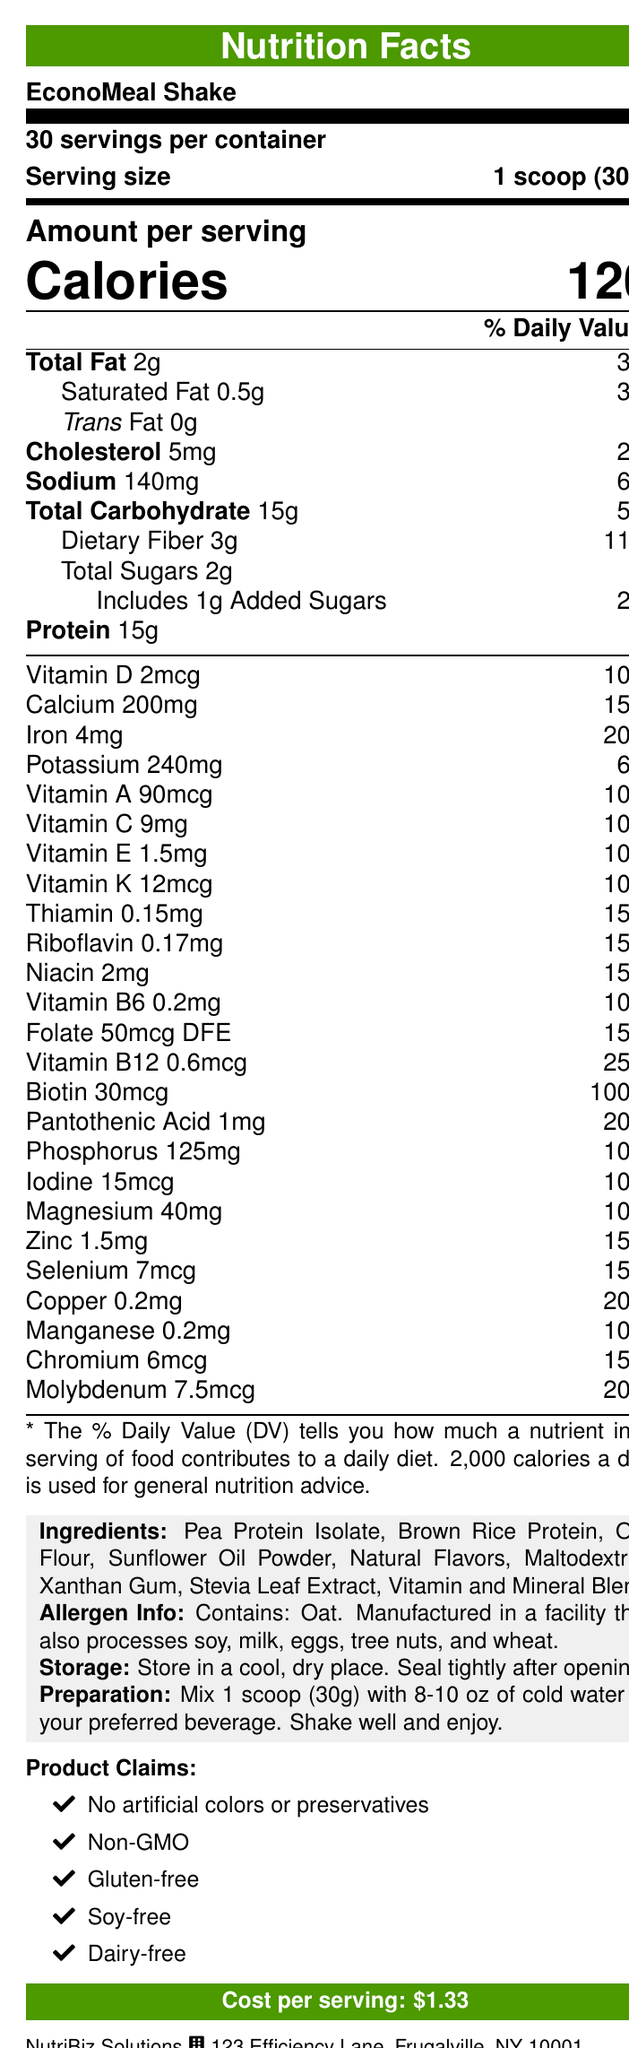what is the product name? The product name is clearly mentioned at the beginning of the document.
Answer: EconoMeal Shake how many servings does the EconoMeal Shake container provide? The document states "30 servings per container."
Answer: 30 servings how many calories are in one serving? The document shows "Calories 120" under the "Amount per serving" section.
Answer: 120 calories what is the serving size? The serving size is listed as "1 scoop (30g)".
Answer: 1 scoop (30g) what is the cost per serving? The cost per serving is highlighted near the bottom of the document.
Answer: $1.33 which nutrient has the highest daily value percentage? A. Iron B. Biotin C. Protein D. Calcium Biotin has the highest daily value percentage at 100%.
Answer: B how much sodium is in one serving? A. 140mg B. 150mg C. 130mg The document states that there are 140mg of sodium per serving.
Answer: A does the product contain any trans fat? According to the document, trans fat is listed as "0g".
Answer: No is the EconoMeal Shake gluten-free? "Gluten-free" is one of the product claims listed in the document.
Answer: Yes is EconoMeal Shake suitable for people with oat allergies? The document mentions that the product contains oat.
Answer: No summarize the main nutritional features of EconoMeal Shake. The summary highlights the main nutritional features, claims, and cost of the EconoMeal Shake based on the information provided in the document.
Answer: The EconoMeal Shake is a budget-friendly meal replacement with 120 calories per serving, providing a balanced mix of macronutrients and essential vitamins and minerals. It is free from artificial colors and preservatives, non-GMO, gluten-free, soy-free, and dairy-free. Each serving costs $1.33. what is the daily value percentage of vitamin D per serving? The document lists vitamin D with a daily value of 10%.
Answer: 10% what is the company address for NutriBiz Solutions? The company's address is provided at the bottom of the document.
Answer: 123 Efficiency Lane, Frugalville, NY 10001 what are the main sources of protein in this shake? These ingredients are listed under the "Ingredients" section.
Answer: Pea Protein Isolate, Brown Rice Protein what allergens are mentioned in the document? The allergen information specifies the presence of oat and lists other potential allergens due to the manufacturing facility.
Answer: Oat. Also processed in a facility that processes soy, milk, eggs, tree nuts, and wheat. which ingredient is used as a sweetener in the EconoMeal Shake? The ingredient list includes Stevia Leaf Extract as a sweetener.
Answer: Stevia Leaf Extract can you determine the exact vitamin and mineral blend components? The document only mentions "Vitamin and Mineral Blend" without specifying the components.
Answer: Cannot be determined how should the EconoMeal Shake be stored? The storage instructions specify these conditions.
Answer: Store in a cool, dry place. Seal tightly after opening. how should you prepare the EconoMeal Shake? The document provides these preparation instructions.
Answer: Mix 1 scoop (30g) with 8-10 oz of cold water or your preferred beverage. Shake well and enjoy. which vitamin has the highest daily value percentage in EconoMeal Shake? The document shows biotin with a daily value of 100%.
Answer: Biotin does the EconoMeal Shake contain any artificial colors or preservatives? "No artificial colors or preservatives" is one of the product claims.
Answer: No what is the customer service number for NutriBiz Solutions? The document lists this number for customer service.
Answer: 1-800-555-SAVE 